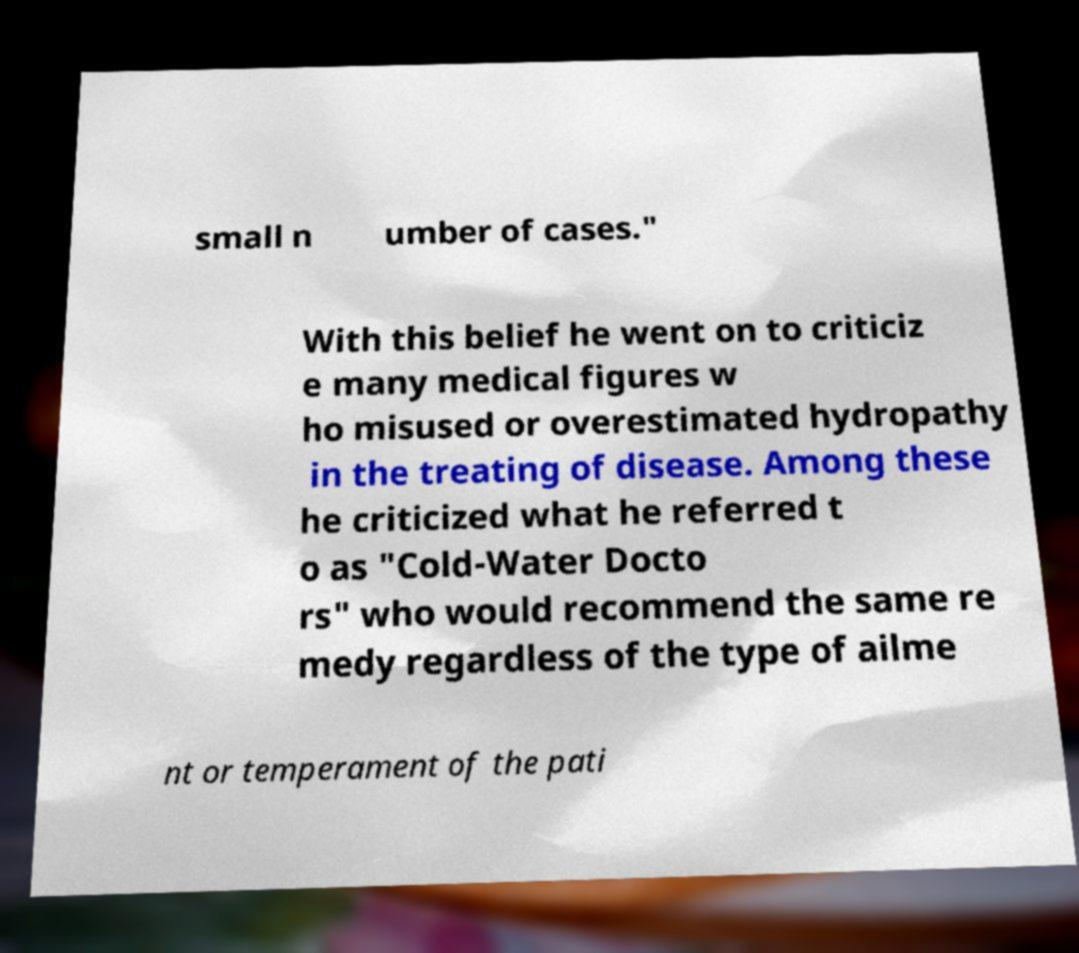Could you extract and type out the text from this image? small n umber of cases." With this belief he went on to criticiz e many medical figures w ho misused or overestimated hydropathy in the treating of disease. Among these he criticized what he referred t o as "Cold-Water Docto rs" who would recommend the same re medy regardless of the type of ailme nt or temperament of the pati 